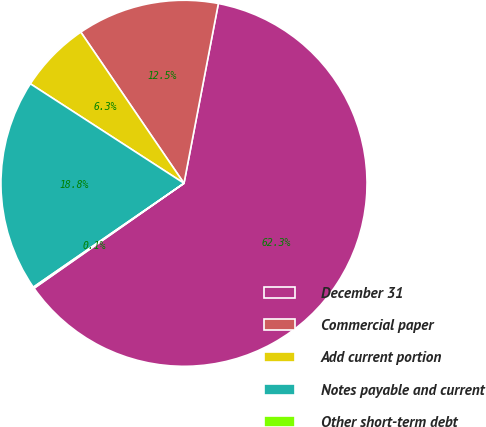Convert chart to OTSL. <chart><loc_0><loc_0><loc_500><loc_500><pie_chart><fcel>December 31<fcel>Commercial paper<fcel>Add current portion<fcel>Notes payable and current<fcel>Other short-term debt<nl><fcel>62.28%<fcel>12.54%<fcel>6.32%<fcel>18.76%<fcel>0.11%<nl></chart> 